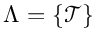<formula> <loc_0><loc_0><loc_500><loc_500>\Lambda = \{ \mathcal { T } \}</formula> 